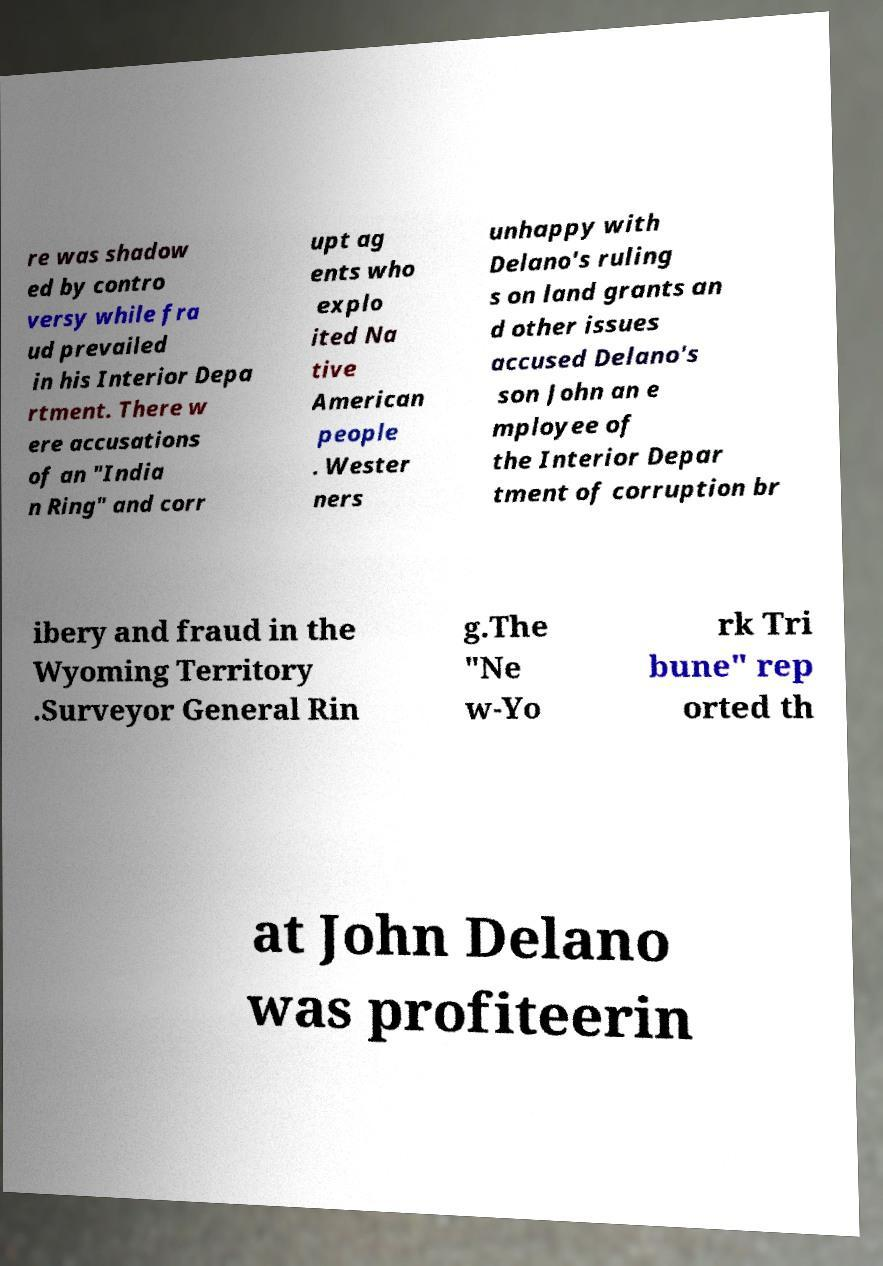Could you extract and type out the text from this image? re was shadow ed by contro versy while fra ud prevailed in his Interior Depa rtment. There w ere accusations of an "India n Ring" and corr upt ag ents who explo ited Na tive American people . Wester ners unhappy with Delano's ruling s on land grants an d other issues accused Delano's son John an e mployee of the Interior Depar tment of corruption br ibery and fraud in the Wyoming Territory .Surveyor General Rin g.The "Ne w-Yo rk Tri bune" rep orted th at John Delano was profiteerin 